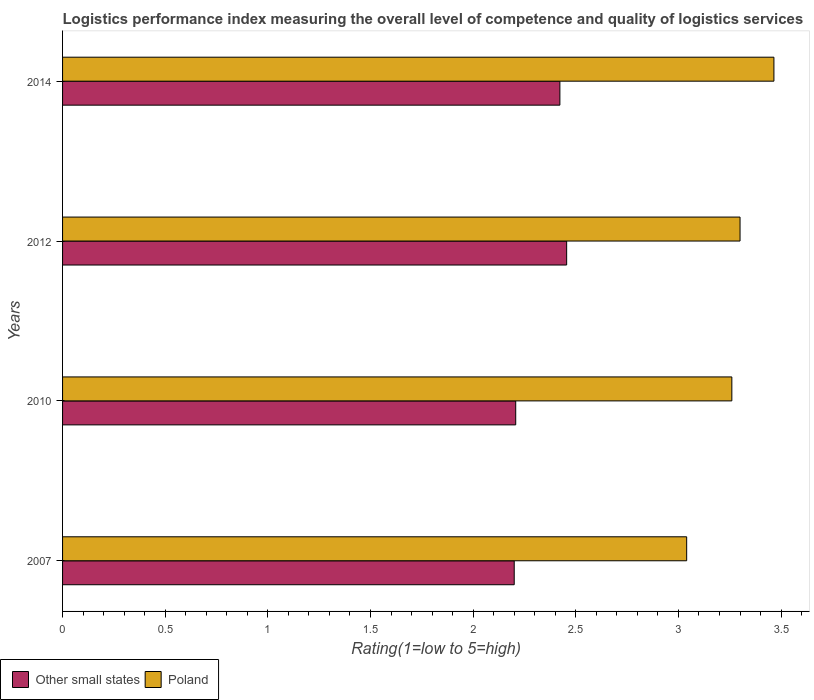How many different coloured bars are there?
Your answer should be compact. 2. How many groups of bars are there?
Provide a short and direct response. 4. Are the number of bars per tick equal to the number of legend labels?
Ensure brevity in your answer.  Yes. Are the number of bars on each tick of the Y-axis equal?
Provide a succinct answer. Yes. How many bars are there on the 3rd tick from the top?
Your answer should be compact. 2. What is the label of the 1st group of bars from the top?
Your response must be concise. 2014. In how many cases, is the number of bars for a given year not equal to the number of legend labels?
Provide a short and direct response. 0. What is the Logistic performance index in Poland in 2007?
Ensure brevity in your answer.  3.04. Across all years, what is the maximum Logistic performance index in Other small states?
Offer a terse response. 2.46. In which year was the Logistic performance index in Poland maximum?
Ensure brevity in your answer.  2014. What is the total Logistic performance index in Poland in the graph?
Keep it short and to the point. 13.07. What is the difference between the Logistic performance index in Poland in 2010 and that in 2012?
Offer a very short reply. -0.04. What is the difference between the Logistic performance index in Other small states in 2010 and the Logistic performance index in Poland in 2012?
Your answer should be very brief. -1.09. What is the average Logistic performance index in Poland per year?
Your answer should be very brief. 3.27. In the year 2014, what is the difference between the Logistic performance index in Other small states and Logistic performance index in Poland?
Give a very brief answer. -1.04. What is the ratio of the Logistic performance index in Other small states in 2007 to that in 2014?
Offer a terse response. 0.91. What is the difference between the highest and the second highest Logistic performance index in Other small states?
Give a very brief answer. 0.03. What is the difference between the highest and the lowest Logistic performance index in Poland?
Provide a short and direct response. 0.43. Is the sum of the Logistic performance index in Poland in 2007 and 2010 greater than the maximum Logistic performance index in Other small states across all years?
Provide a short and direct response. Yes. What does the 2nd bar from the bottom in 2010 represents?
Your response must be concise. Poland. How many bars are there?
Your response must be concise. 8. Are all the bars in the graph horizontal?
Ensure brevity in your answer.  Yes. What is the difference between two consecutive major ticks on the X-axis?
Your answer should be very brief. 0.5. Does the graph contain any zero values?
Ensure brevity in your answer.  No. Does the graph contain grids?
Ensure brevity in your answer.  No. How many legend labels are there?
Your answer should be very brief. 2. What is the title of the graph?
Ensure brevity in your answer.  Logistics performance index measuring the overall level of competence and quality of logistics services. What is the label or title of the X-axis?
Offer a very short reply. Rating(1=low to 5=high). What is the label or title of the Y-axis?
Make the answer very short. Years. What is the Rating(1=low to 5=high) of Other small states in 2007?
Offer a terse response. 2.2. What is the Rating(1=low to 5=high) in Poland in 2007?
Give a very brief answer. 3.04. What is the Rating(1=low to 5=high) in Other small states in 2010?
Make the answer very short. 2.21. What is the Rating(1=low to 5=high) in Poland in 2010?
Offer a very short reply. 3.26. What is the Rating(1=low to 5=high) of Other small states in 2012?
Give a very brief answer. 2.46. What is the Rating(1=low to 5=high) in Other small states in 2014?
Provide a short and direct response. 2.42. What is the Rating(1=low to 5=high) in Poland in 2014?
Keep it short and to the point. 3.47. Across all years, what is the maximum Rating(1=low to 5=high) of Other small states?
Provide a short and direct response. 2.46. Across all years, what is the maximum Rating(1=low to 5=high) of Poland?
Make the answer very short. 3.47. Across all years, what is the minimum Rating(1=low to 5=high) in Other small states?
Provide a short and direct response. 2.2. Across all years, what is the minimum Rating(1=low to 5=high) of Poland?
Give a very brief answer. 3.04. What is the total Rating(1=low to 5=high) of Other small states in the graph?
Keep it short and to the point. 9.29. What is the total Rating(1=low to 5=high) of Poland in the graph?
Make the answer very short. 13.06. What is the difference between the Rating(1=low to 5=high) of Other small states in 2007 and that in 2010?
Give a very brief answer. -0.01. What is the difference between the Rating(1=low to 5=high) in Poland in 2007 and that in 2010?
Keep it short and to the point. -0.22. What is the difference between the Rating(1=low to 5=high) of Other small states in 2007 and that in 2012?
Your answer should be very brief. -0.26. What is the difference between the Rating(1=low to 5=high) of Poland in 2007 and that in 2012?
Your answer should be compact. -0.26. What is the difference between the Rating(1=low to 5=high) in Other small states in 2007 and that in 2014?
Your response must be concise. -0.22. What is the difference between the Rating(1=low to 5=high) in Poland in 2007 and that in 2014?
Make the answer very short. -0.42. What is the difference between the Rating(1=low to 5=high) in Other small states in 2010 and that in 2012?
Your response must be concise. -0.25. What is the difference between the Rating(1=low to 5=high) of Poland in 2010 and that in 2012?
Provide a short and direct response. -0.04. What is the difference between the Rating(1=low to 5=high) in Other small states in 2010 and that in 2014?
Your response must be concise. -0.22. What is the difference between the Rating(1=low to 5=high) of Poland in 2010 and that in 2014?
Your response must be concise. -0.2. What is the difference between the Rating(1=low to 5=high) of Other small states in 2012 and that in 2014?
Give a very brief answer. 0.03. What is the difference between the Rating(1=low to 5=high) of Poland in 2012 and that in 2014?
Give a very brief answer. -0.17. What is the difference between the Rating(1=low to 5=high) of Other small states in 2007 and the Rating(1=low to 5=high) of Poland in 2010?
Give a very brief answer. -1.06. What is the difference between the Rating(1=low to 5=high) of Other small states in 2007 and the Rating(1=low to 5=high) of Poland in 2014?
Ensure brevity in your answer.  -1.26. What is the difference between the Rating(1=low to 5=high) of Other small states in 2010 and the Rating(1=low to 5=high) of Poland in 2012?
Make the answer very short. -1.09. What is the difference between the Rating(1=low to 5=high) of Other small states in 2010 and the Rating(1=low to 5=high) of Poland in 2014?
Provide a succinct answer. -1.26. What is the difference between the Rating(1=low to 5=high) of Other small states in 2012 and the Rating(1=low to 5=high) of Poland in 2014?
Offer a terse response. -1.01. What is the average Rating(1=low to 5=high) of Other small states per year?
Make the answer very short. 2.32. What is the average Rating(1=low to 5=high) in Poland per year?
Your response must be concise. 3.27. In the year 2007, what is the difference between the Rating(1=low to 5=high) in Other small states and Rating(1=low to 5=high) in Poland?
Offer a terse response. -0.84. In the year 2010, what is the difference between the Rating(1=low to 5=high) of Other small states and Rating(1=low to 5=high) of Poland?
Offer a terse response. -1.05. In the year 2012, what is the difference between the Rating(1=low to 5=high) of Other small states and Rating(1=low to 5=high) of Poland?
Provide a succinct answer. -0.84. In the year 2014, what is the difference between the Rating(1=low to 5=high) of Other small states and Rating(1=low to 5=high) of Poland?
Provide a succinct answer. -1.04. What is the ratio of the Rating(1=low to 5=high) of Poland in 2007 to that in 2010?
Your answer should be compact. 0.93. What is the ratio of the Rating(1=low to 5=high) in Other small states in 2007 to that in 2012?
Provide a short and direct response. 0.9. What is the ratio of the Rating(1=low to 5=high) in Poland in 2007 to that in 2012?
Make the answer very short. 0.92. What is the ratio of the Rating(1=low to 5=high) in Other small states in 2007 to that in 2014?
Give a very brief answer. 0.91. What is the ratio of the Rating(1=low to 5=high) of Poland in 2007 to that in 2014?
Ensure brevity in your answer.  0.88. What is the ratio of the Rating(1=low to 5=high) in Other small states in 2010 to that in 2012?
Your answer should be very brief. 0.9. What is the ratio of the Rating(1=low to 5=high) of Poland in 2010 to that in 2012?
Provide a succinct answer. 0.99. What is the ratio of the Rating(1=low to 5=high) of Other small states in 2010 to that in 2014?
Your response must be concise. 0.91. What is the ratio of the Rating(1=low to 5=high) of Poland in 2010 to that in 2014?
Your response must be concise. 0.94. What is the ratio of the Rating(1=low to 5=high) of Other small states in 2012 to that in 2014?
Provide a short and direct response. 1.01. What is the ratio of the Rating(1=low to 5=high) in Poland in 2012 to that in 2014?
Your answer should be very brief. 0.95. What is the difference between the highest and the second highest Rating(1=low to 5=high) of Other small states?
Offer a terse response. 0.03. What is the difference between the highest and the second highest Rating(1=low to 5=high) of Poland?
Your answer should be very brief. 0.17. What is the difference between the highest and the lowest Rating(1=low to 5=high) of Other small states?
Provide a succinct answer. 0.26. What is the difference between the highest and the lowest Rating(1=low to 5=high) of Poland?
Ensure brevity in your answer.  0.42. 